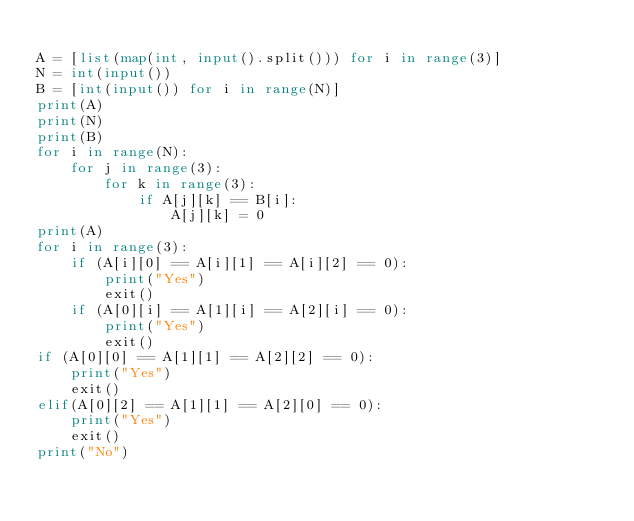<code> <loc_0><loc_0><loc_500><loc_500><_Python_>
A = [list(map(int, input().split())) for i in range(3)]
N = int(input())
B = [int(input()) for i in range(N)]
print(A)
print(N)
print(B)
for i in range(N):
    for j in range(3):
        for k in range(3):
            if A[j][k] == B[i]:
                A[j][k] = 0
print(A)
for i in range(3):
    if (A[i][0] == A[i][1] == A[i][2] == 0):
        print("Yes")
        exit()
    if (A[0][i] == A[1][i] == A[2][i] == 0):
        print("Yes")
        exit()
if (A[0][0] == A[1][1] == A[2][2] == 0):
    print("Yes")
    exit()
elif(A[0][2] == A[1][1] == A[2][0] == 0):
    print("Yes")
    exit()
print("No")</code> 